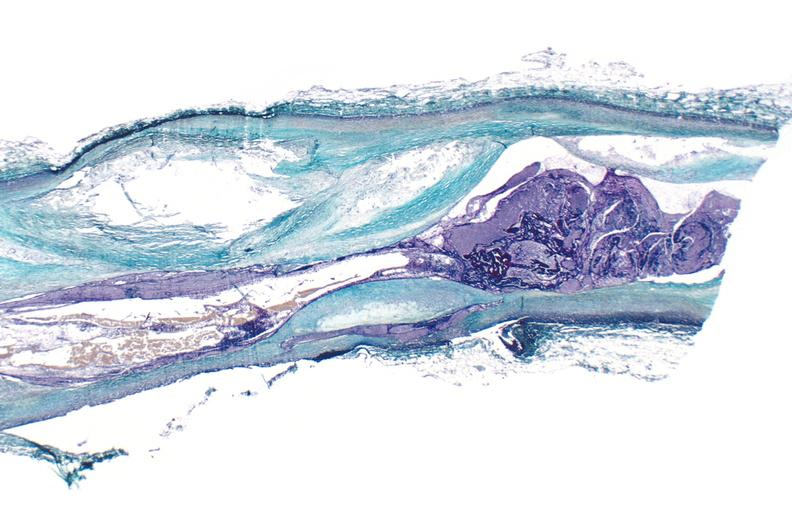s 7182 and 7183 present?
Answer the question using a single word or phrase. No 